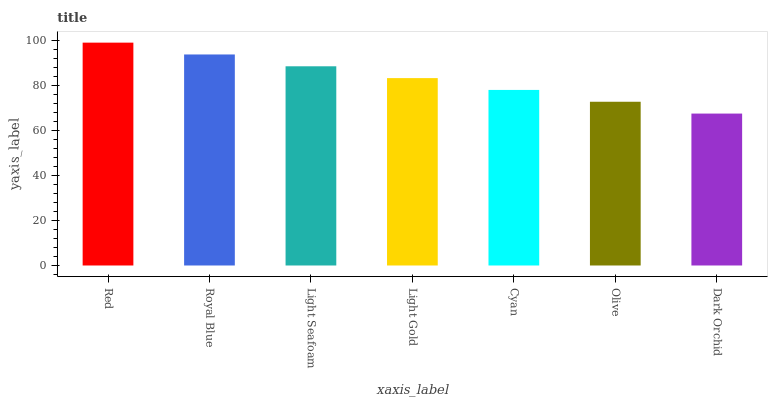Is Red the maximum?
Answer yes or no. Yes. Is Royal Blue the minimum?
Answer yes or no. No. Is Royal Blue the maximum?
Answer yes or no. No. Is Red greater than Royal Blue?
Answer yes or no. Yes. Is Royal Blue less than Red?
Answer yes or no. Yes. Is Royal Blue greater than Red?
Answer yes or no. No. Is Red less than Royal Blue?
Answer yes or no. No. Is Light Gold the high median?
Answer yes or no. Yes. Is Light Gold the low median?
Answer yes or no. Yes. Is Dark Orchid the high median?
Answer yes or no. No. Is Olive the low median?
Answer yes or no. No. 